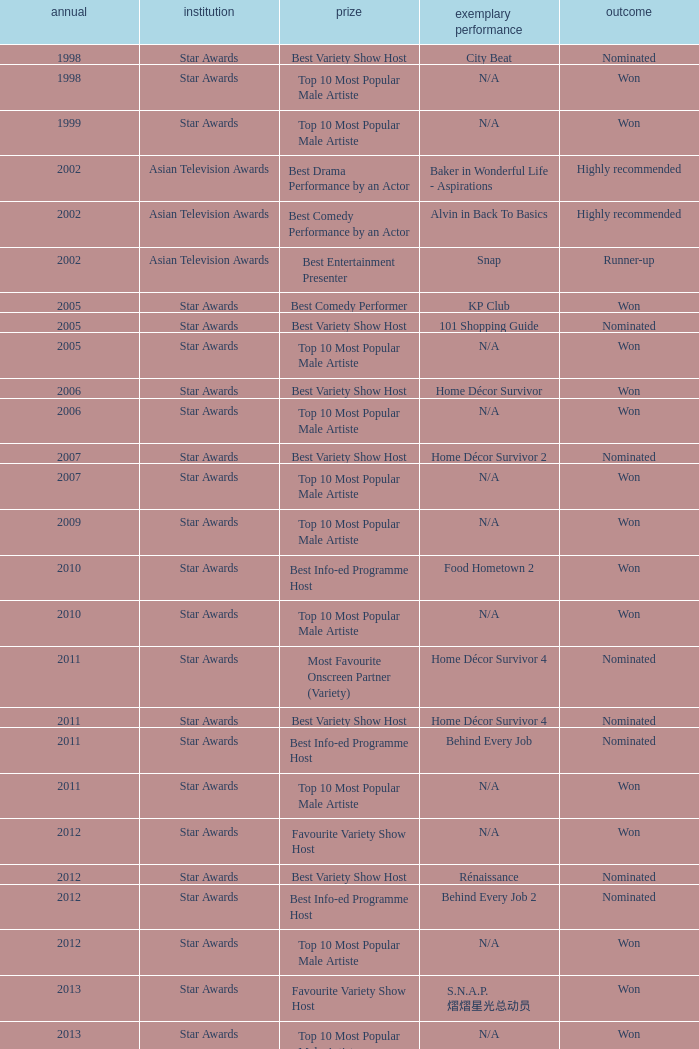What is the award for the Star Awards earlier than 2005 and the result is won? Top 10 Most Popular Male Artiste, Top 10 Most Popular Male Artiste. 